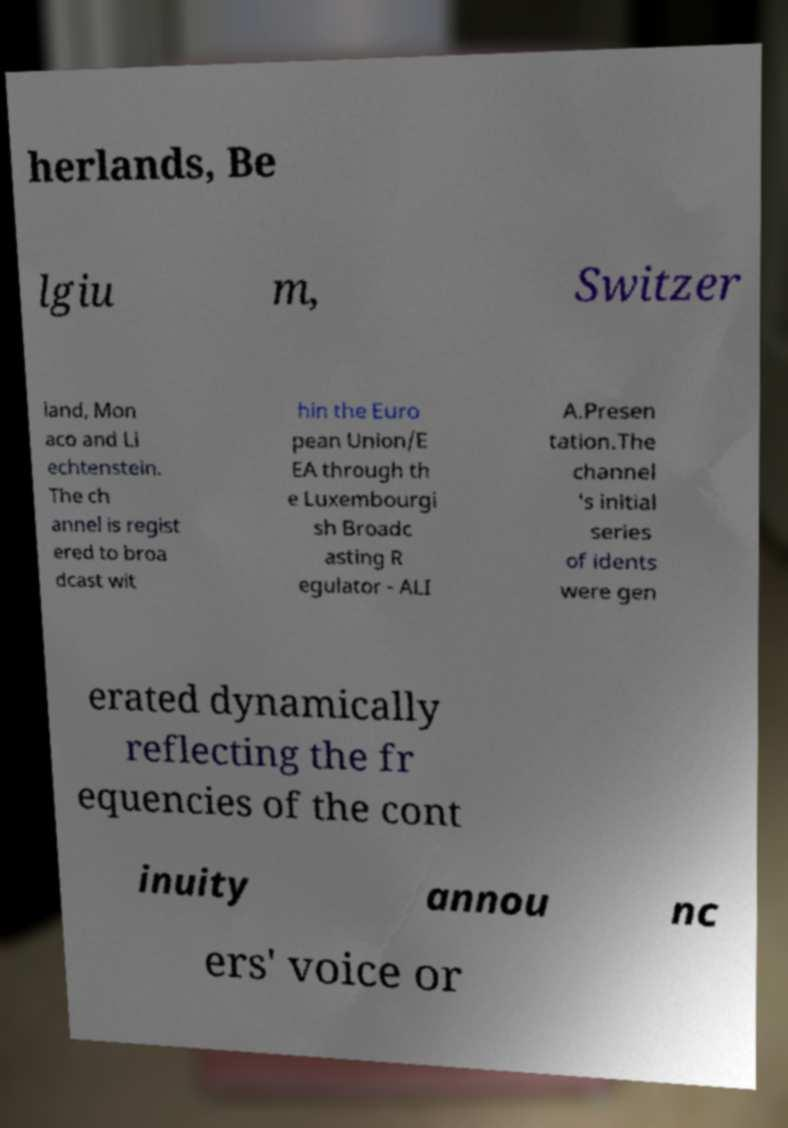Could you extract and type out the text from this image? herlands, Be lgiu m, Switzer land, Mon aco and Li echtenstein. The ch annel is regist ered to broa dcast wit hin the Euro pean Union/E EA through th e Luxembourgi sh Broadc asting R egulator - ALI A.Presen tation.The channel 's initial series of idents were gen erated dynamically reflecting the fr equencies of the cont inuity annou nc ers' voice or 